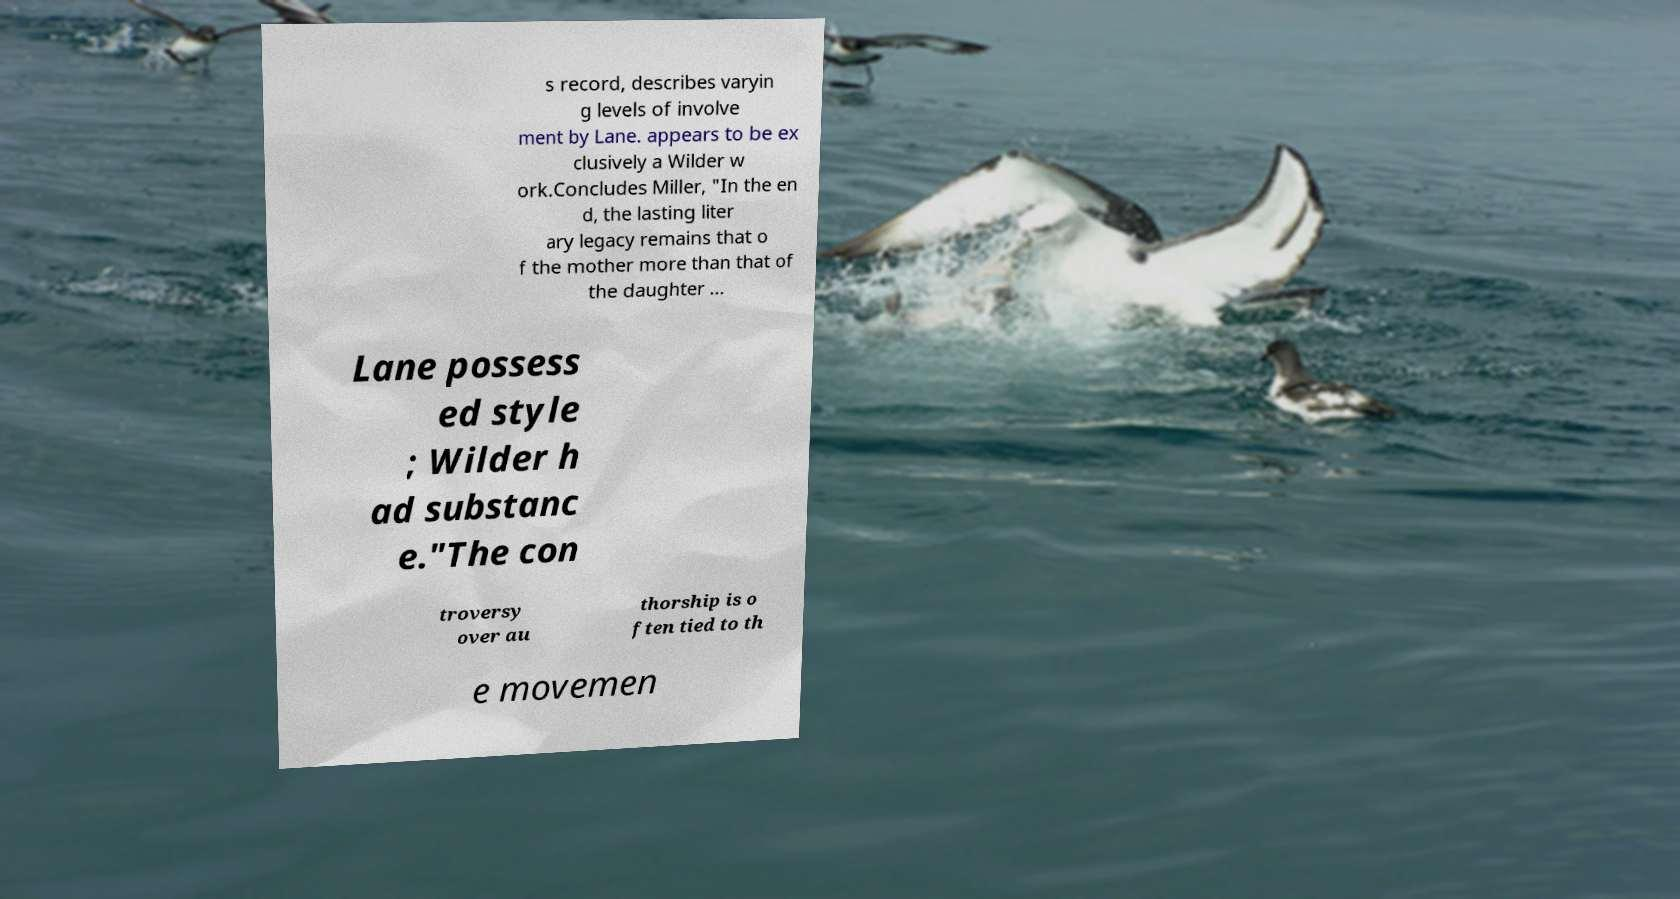Can you read and provide the text displayed in the image?This photo seems to have some interesting text. Can you extract and type it out for me? s record, describes varyin g levels of involve ment by Lane. appears to be ex clusively a Wilder w ork.Concludes Miller, "In the en d, the lasting liter ary legacy remains that o f the mother more than that of the daughter ... Lane possess ed style ; Wilder h ad substanc e."The con troversy over au thorship is o ften tied to th e movemen 